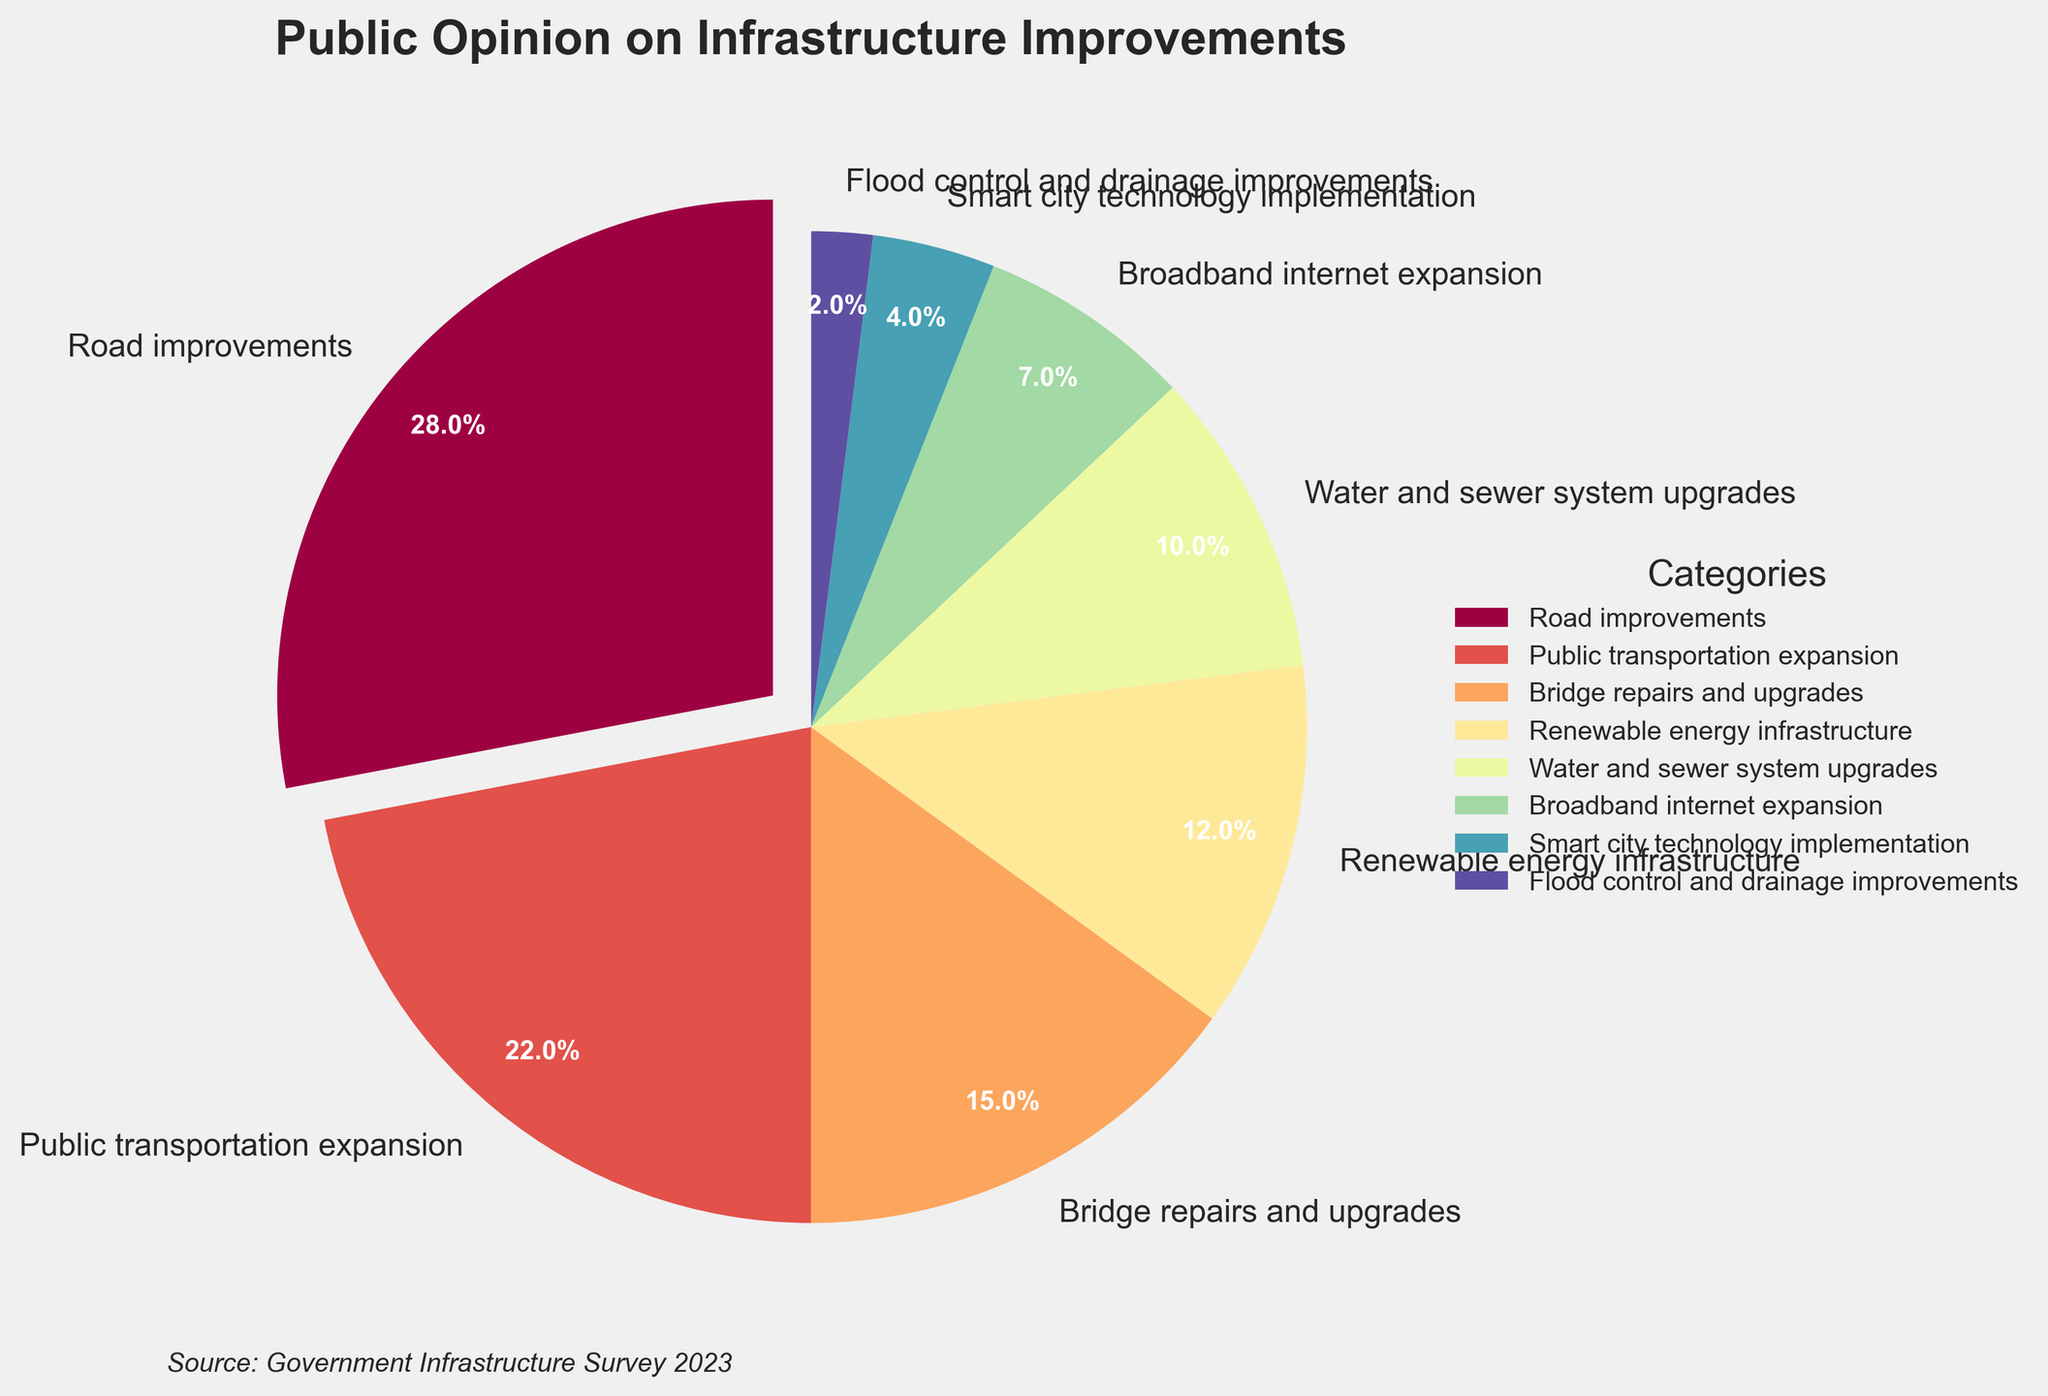What's the most popular category for infrastructure improvement according to public opinion? The slice with the largest percentage indicates the most popular category. In this pie chart, "Road improvements" has the largest slice, which is 28%.
Answer: Road improvements Among the listed categories, which one received the least support? The smallest slice represents the least supported category. In this case, "Flood control and drainage improvements" has the smallest percentage at 2%.
Answer: Flood control and drainage improvements How much more popular is "Road improvements" compared to "Flood control and drainage improvements"? Subtract the percentage of the least popular category from the most popular one. "Road improvements" has 28% and "Flood control and drainage improvements" has 2%, so the difference is 28% - 2% = 26%.
Answer: 26% What is the combined percentage of public support for "Public transportation expansion" and "Bridge repairs and upgrades"? Add the percentages for both categories. "Public transportation expansion" has 22% and "Bridge repairs and upgrades" has 15%, so the total is 22% + 15% = 37%.
Answer: 37% Are there more people supporting "Renewable energy infrastructure" or "Water and sewer system upgrades"? Compare the slices representing these two categories. "Renewable energy infrastructure" has 12% and "Water and sewer system upgrades" has 10%, so more people support "Renewable energy infrastructure."
Answer: Renewable energy infrastructure How many categories have received a public support percentage of at least 10%? Count the categories with percentages greater than or equal to 10%. The relevant categories are "Road improvements" (28%), "Public transportation expansion" (22%), "Bridge repairs and upgrades" (15%), "Renewable energy infrastructure" (12%), and "Water and sewer system upgrades" (10%). There are 5 such categories.
Answer: 5 What percentage of public support does "Broadband internet expansion" and "Smart city technology implementation" represent combined? Add the percentages for these two categories. "Broadband internet expansion" has 7% and "Smart city technology implementation" has 4%, so the total is 7% + 4% = 11%.
Answer: 11% Which category has the second-highest public support? The second largest slice represents the category with the second-highest support. "Public transportation expansion" has 22%, making it second after "Road improvements."
Answer: Public transportation expansion What fraction of total public support is directed towards "Bridge repairs and upgrades"? Divide the percentage of "Bridge repairs and upgrades" by the total percentage (which is 100%). "Bridge repairs and upgrades" has 15%, so the fraction is 15/100 = 3/20.
Answer: 3/20 Does "Water and sewer system upgrades" receive more support than "Smart city technology implementation"? Compare the slices for both categories. "Water and sewer system upgrades" has 10% while "Smart city technology implementation" has 4%, so "Water and sewer system upgrades" receives more support.
Answer: Yes 